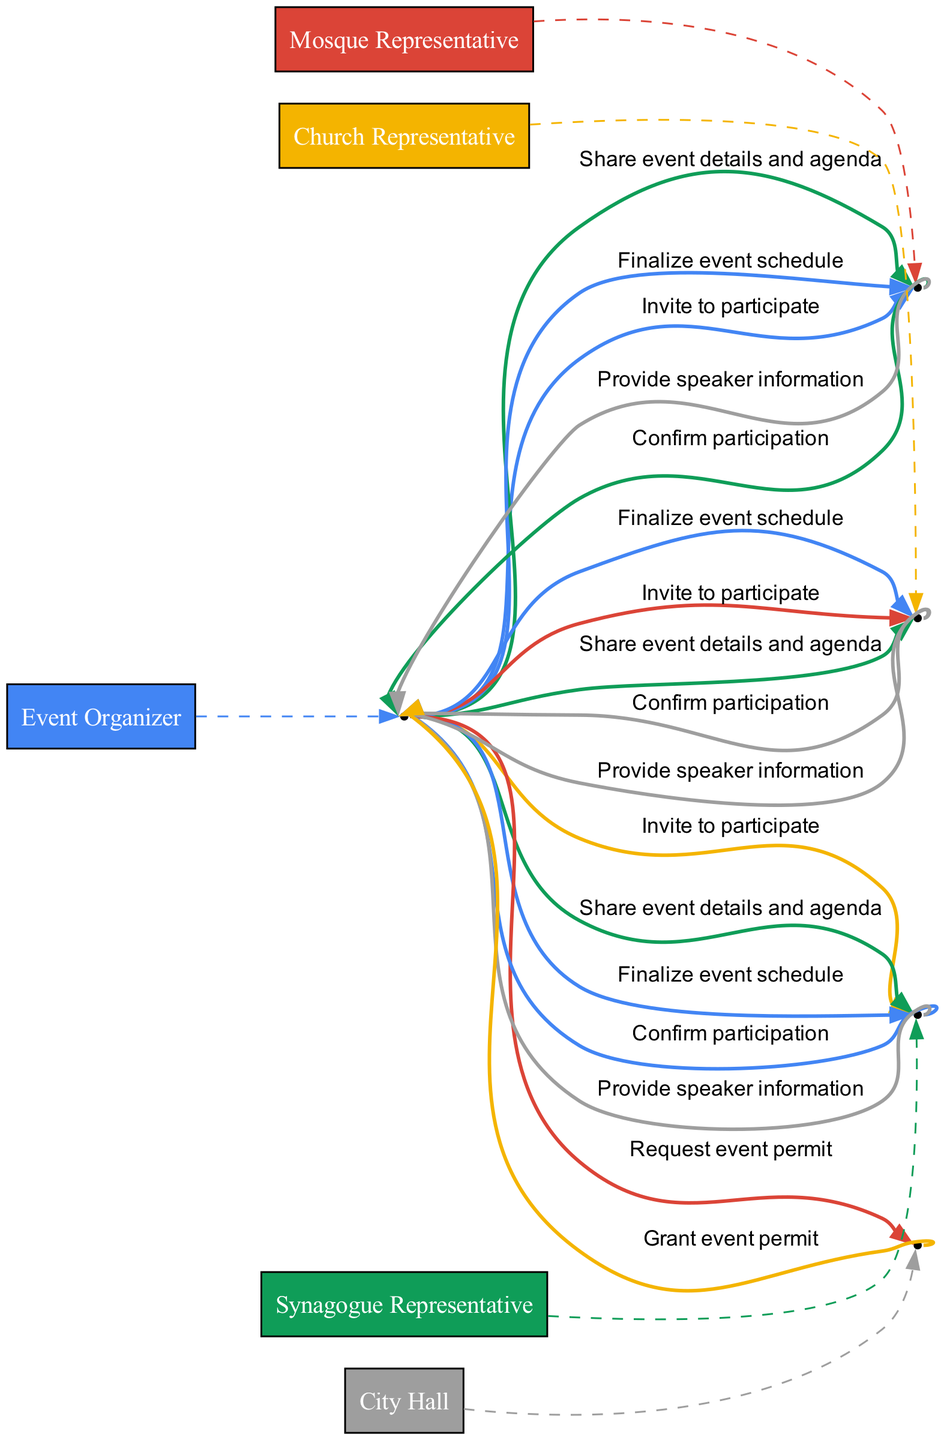what is the first action taken by the Event Organizer? The first action taken by the Event Organizer is to invite the Mosque Representative to participate. This can be seen at the very beginning of the sequence where the Event Organizer sends the invite.
Answer: Invite to participate how many representatives were invited to participate? The Event Organizer invited three representatives: the Mosque Representative, the Church Representative, and the Synagogue Representative. This can be counted directly from the connections extending from the Event Organizer with the invitation message.
Answer: Three who confirms participation after being invited by the Event Organizer? The representatives who confirm participation after being invited by the Event Organizer are the Mosque Representative, Church Representative, and Synagogue Representative. Each of them responds with a confirmation message.
Answer: All Representatives what is the action taken by City Hall following the Event Organizer’s request? After the Event Organizer requests an event permit, City Hall grants the event permit. This is evident in the directed edge connecting the Event Organizer's request to City Hall's response.
Answer: Grant event permit which representatives provide speaker information? All representatives, which include the Mosque Representative, Church Representative, and Synagogue Representative, provide speaker information. This is demonstrated in the section of the diagram where it states that all representatives respond to the Event Organizer.
Answer: All Representatives what is the final action taken by the Event Organizer in this sequence? The final action taken by the Event Organizer is to finalize the event schedule. This is indicated by the last message flow in the diagram.
Answer: Finalize event schedule which actor receives the most messages from the Event Organizer? The Event Organizer sends messages to almost all actors, but specifically, the City Hall receives one message for event permit, while the All Representatives receive three messages in total, making the Event Organizer the most interacted with. However, if counting direct messages, All Representatives receive more.
Answer: All Representatives what role does the Event Organizer play in this sequence diagram? The Event Organizer acts as the central coordinator who initiates the process by inviting representatives, requesting permits, sharing event details, and finalizing the schedule. This can be seen from the multiple messages originating from the Event Organizer.
Answer: Coordinator 